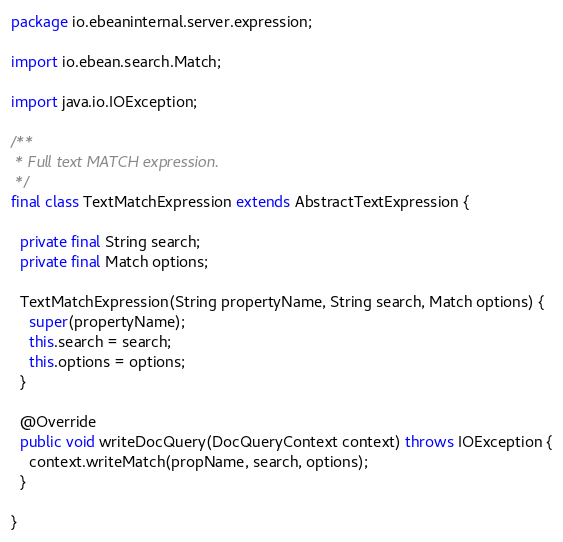Convert code to text. <code><loc_0><loc_0><loc_500><loc_500><_Java_>package io.ebeaninternal.server.expression;

import io.ebean.search.Match;

import java.io.IOException;

/**
 * Full text MATCH expression.
 */
final class TextMatchExpression extends AbstractTextExpression {

  private final String search;
  private final Match options;

  TextMatchExpression(String propertyName, String search, Match options) {
    super(propertyName);
    this.search = search;
    this.options = options;
  }

  @Override
  public void writeDocQuery(DocQueryContext context) throws IOException {
    context.writeMatch(propName, search, options);
  }

}
</code> 